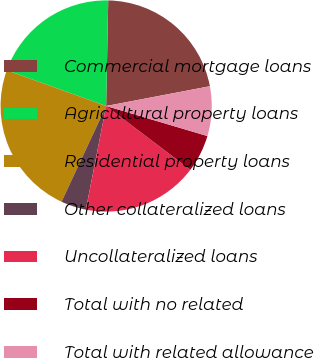<chart> <loc_0><loc_0><loc_500><loc_500><pie_chart><fcel>Commercial mortgage loans<fcel>Agricultural property loans<fcel>Residential property loans<fcel>Other collateralized loans<fcel>Uncollateralized loans<fcel>Total with no related<fcel>Total with related allowance<nl><fcel>21.69%<fcel>19.82%<fcel>23.55%<fcel>3.86%<fcel>17.76%<fcel>5.73%<fcel>7.59%<nl></chart> 